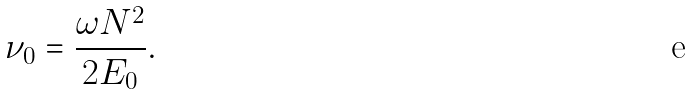<formula> <loc_0><loc_0><loc_500><loc_500>\nu _ { 0 } = \frac { \omega N ^ { 2 } } { 2 E _ { 0 } } .</formula> 